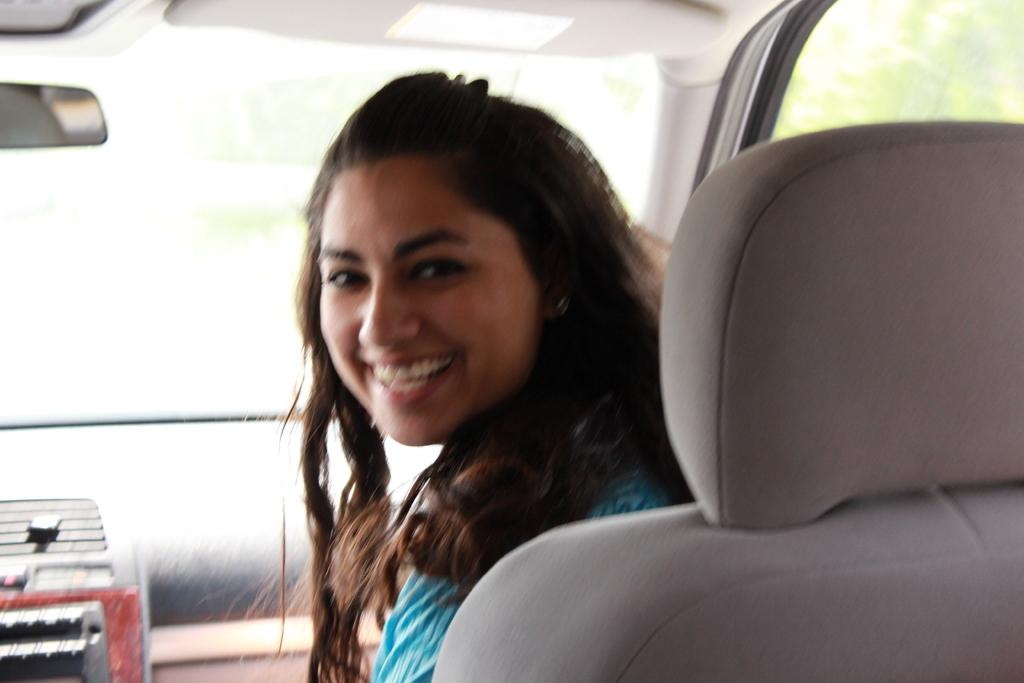Who is the main subject in the image? There is a woman in the image. What is the woman doing in the image? The woman is sitting on a vehicle. What is the woman's facial expression in the image? The woman is smiling. What type of lumber is being used to cover the woman's payment in the image? There is no mention of lumber, covering, or payment in the image. The image only shows a woman sitting on a vehicle and smiling. 